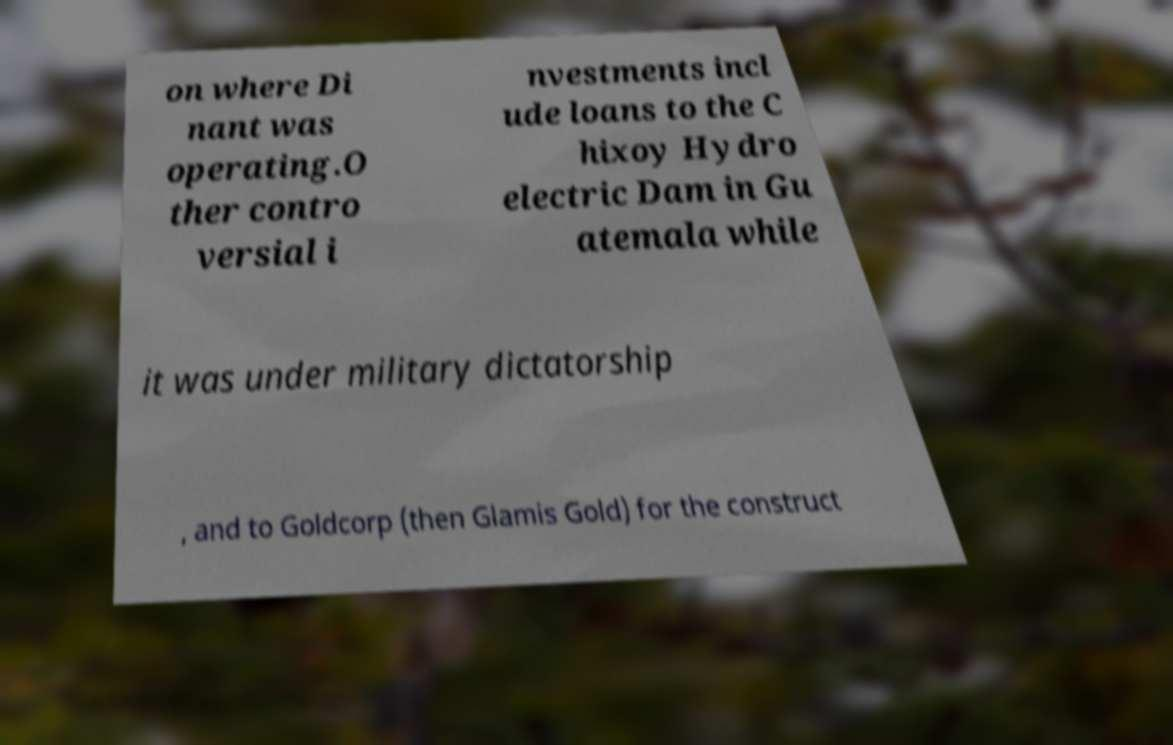Can you read and provide the text displayed in the image?This photo seems to have some interesting text. Can you extract and type it out for me? on where Di nant was operating.O ther contro versial i nvestments incl ude loans to the C hixoy Hydro electric Dam in Gu atemala while it was under military dictatorship , and to Goldcorp (then Glamis Gold) for the construct 